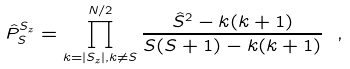<formula> <loc_0><loc_0><loc_500><loc_500>\hat { P } _ { S } ^ { S _ { z } } = \prod _ { k = | S _ { z } | , k \neq S } ^ { N / 2 } \frac { \hat { S } ^ { 2 } - k ( k + 1 ) } { S ( S + 1 ) - k ( k + 1 ) } \ ,</formula> 